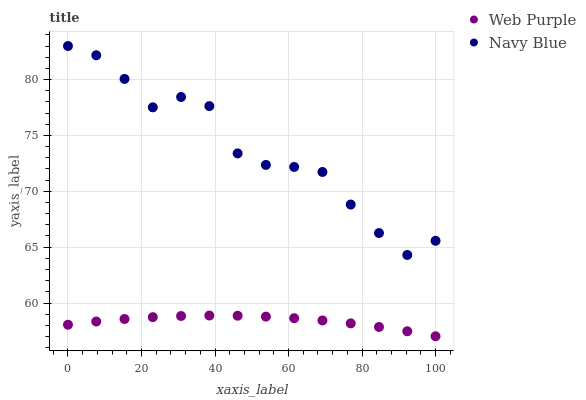Does Web Purple have the minimum area under the curve?
Answer yes or no. Yes. Does Navy Blue have the maximum area under the curve?
Answer yes or no. Yes. Does Web Purple have the maximum area under the curve?
Answer yes or no. No. Is Web Purple the smoothest?
Answer yes or no. Yes. Is Navy Blue the roughest?
Answer yes or no. Yes. Is Web Purple the roughest?
Answer yes or no. No. Does Web Purple have the lowest value?
Answer yes or no. Yes. Does Navy Blue have the highest value?
Answer yes or no. Yes. Does Web Purple have the highest value?
Answer yes or no. No. Is Web Purple less than Navy Blue?
Answer yes or no. Yes. Is Navy Blue greater than Web Purple?
Answer yes or no. Yes. Does Web Purple intersect Navy Blue?
Answer yes or no. No. 